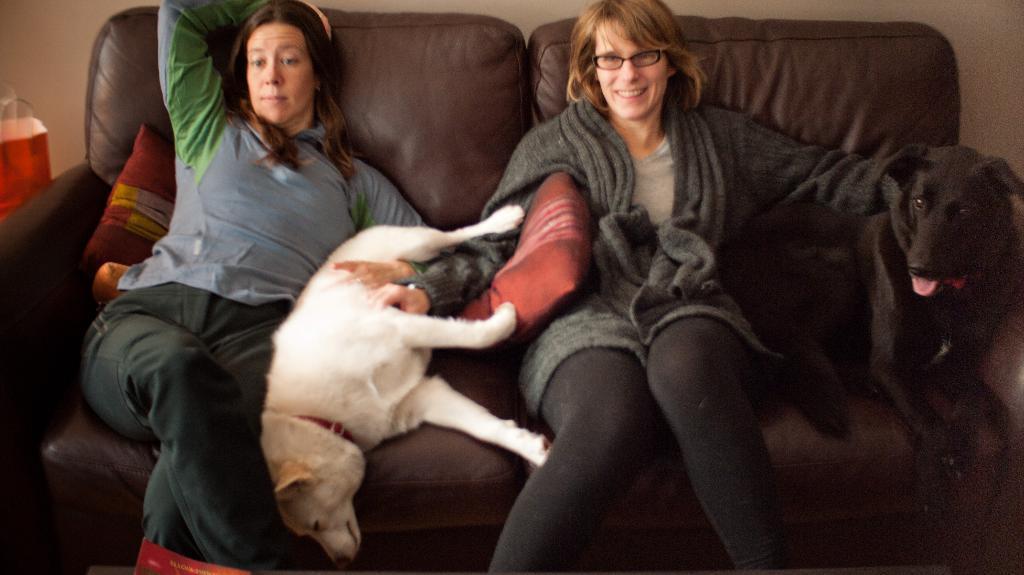Could you give a brief overview of what you see in this image? In this image we can see there are two persons and dogs on the couch and there are pillows. And we can see the wall and cover. 